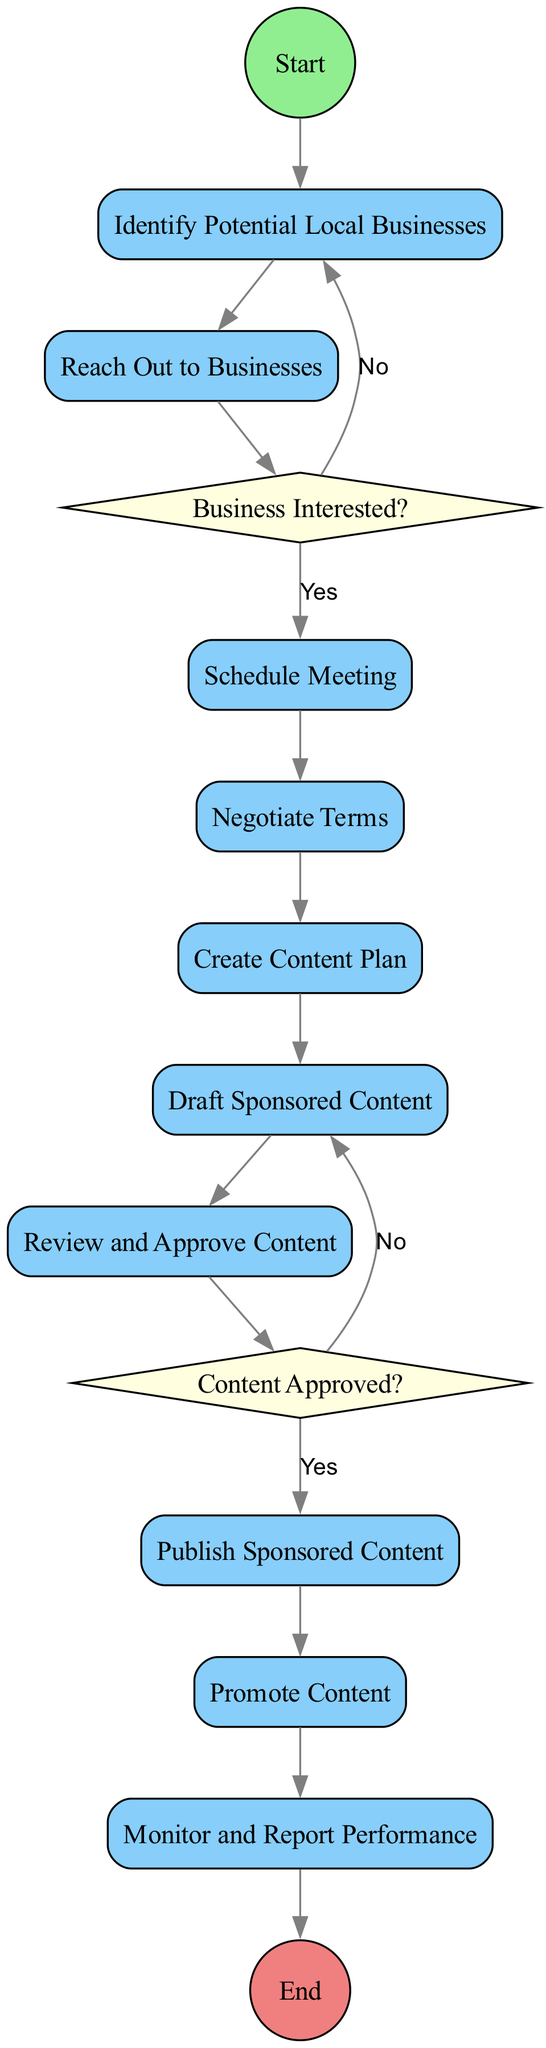What is the first action in the workflow? The first action as represented by the diagram after the start node is "Identify Potential Local Businesses." It is the first step performed in the workflow process.
Answer: Identify Potential Local Businesses How many actions are present in the diagram? The diagram contains a total of ten action nodes outlining the steps to be taken in the workflow.
Answer: Ten What happens if the business is not interested? If the local business is not interested as indicated by the decision node "Business Interested?", the workflow loops back to "Reach Out to Businesses" for further contact attempts.
Answer: Reach Out to Businesses What is required after drafting the sponsored content? After drafting the sponsored content, the next step required is to "Review and Approve Content," where the draft is sent for feedback and approval.
Answer: Review and Approve Content How many decision nodes are in the diagram? The diagram contains two decision nodes that help direct the flow based on the responses received during the collaboration process.
Answer: Two What do you do if the content is not approved? If the content is not approved as indicated by the decision node "Content Approved?", the workflow directs back to "Draft Sponsored Content" to make necessary revisions.
Answer: Draft Sponsored Content What is the last action before reaching the end node? The last action before reaching the end node is "Monitor and Report Performance," which involves tracking the sponsored content performance and reporting it to the local business.
Answer: Monitor and Report Performance What type of shape represents the action nodes? The action nodes are represented by rectangular shapes that are filled and rounded, as per the specific styling for those nodes in the diagram.
Answer: Rectangle 